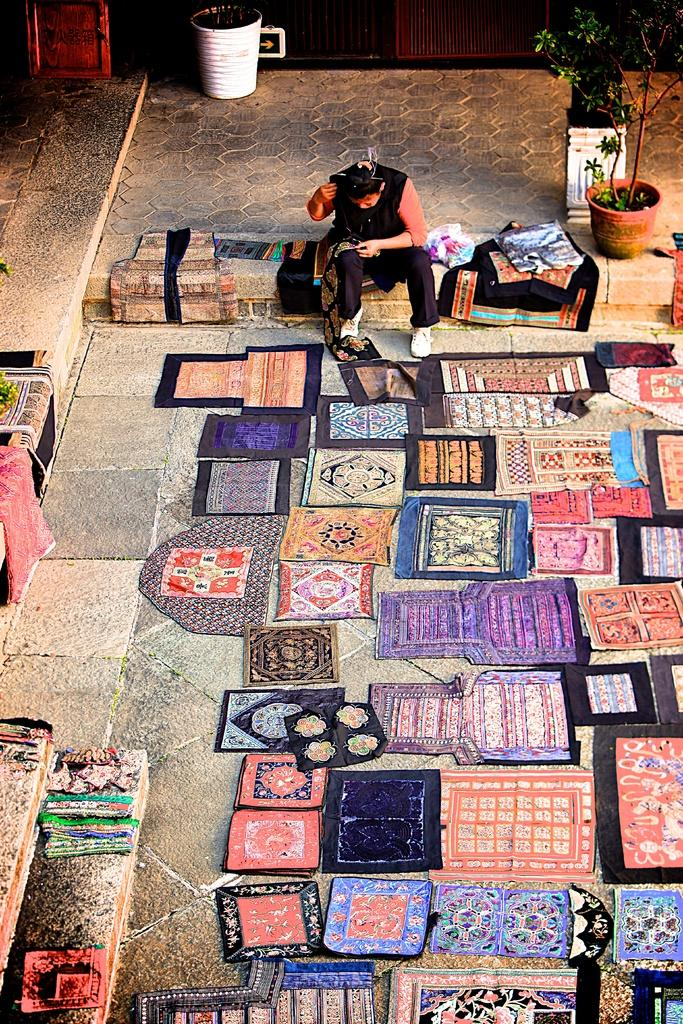What is on the ground in the image? There are mats on the ground in the image. What is the person in the image doing? There is a person sitting on the mats. What else can be seen in the image besides the mats and the person? There are plants visible in the image. What color is the person's wrist in the image? The provided facts do not mention the color of the person's wrist, and there is no indication that the wrist is visible in the image. How many stomachs does the plant have in the image? Plants do not have stomachs, so this question cannot be answered based on the provided facts. 